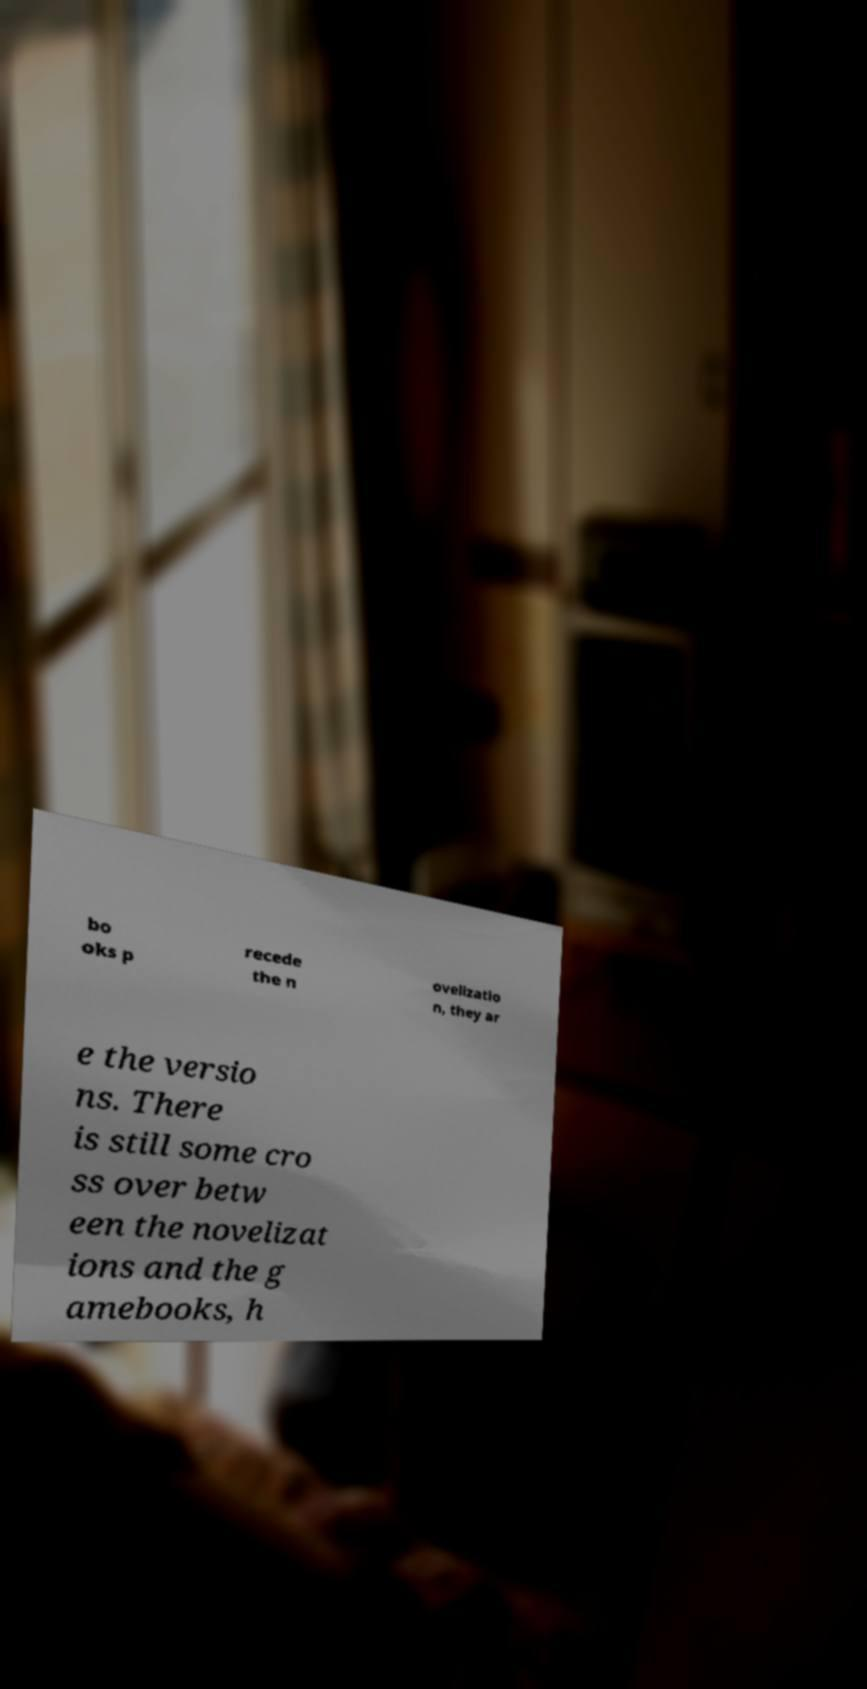Can you accurately transcribe the text from the provided image for me? bo oks p recede the n ovelizatio n, they ar e the versio ns. There is still some cro ss over betw een the novelizat ions and the g amebooks, h 